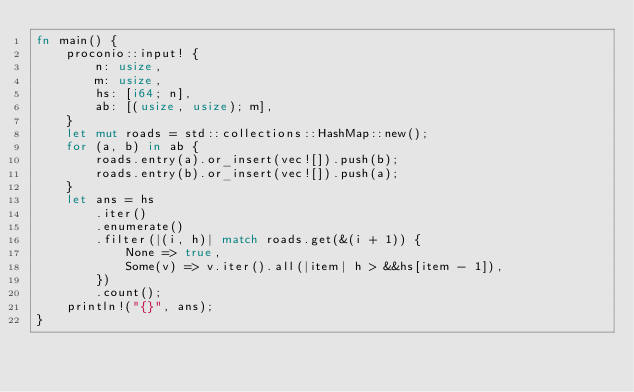<code> <loc_0><loc_0><loc_500><loc_500><_Rust_>fn main() {
    proconio::input! {
        n: usize,
        m: usize,
        hs: [i64; n],
        ab: [(usize, usize); m],
    }
    let mut roads = std::collections::HashMap::new();
    for (a, b) in ab {
        roads.entry(a).or_insert(vec![]).push(b);
        roads.entry(b).or_insert(vec![]).push(a);
    }
    let ans = hs
        .iter()
        .enumerate()
        .filter(|(i, h)| match roads.get(&(i + 1)) {
            None => true,
            Some(v) => v.iter().all(|item| h > &&hs[item - 1]),
        })
        .count();
    println!("{}", ans);
}
</code> 